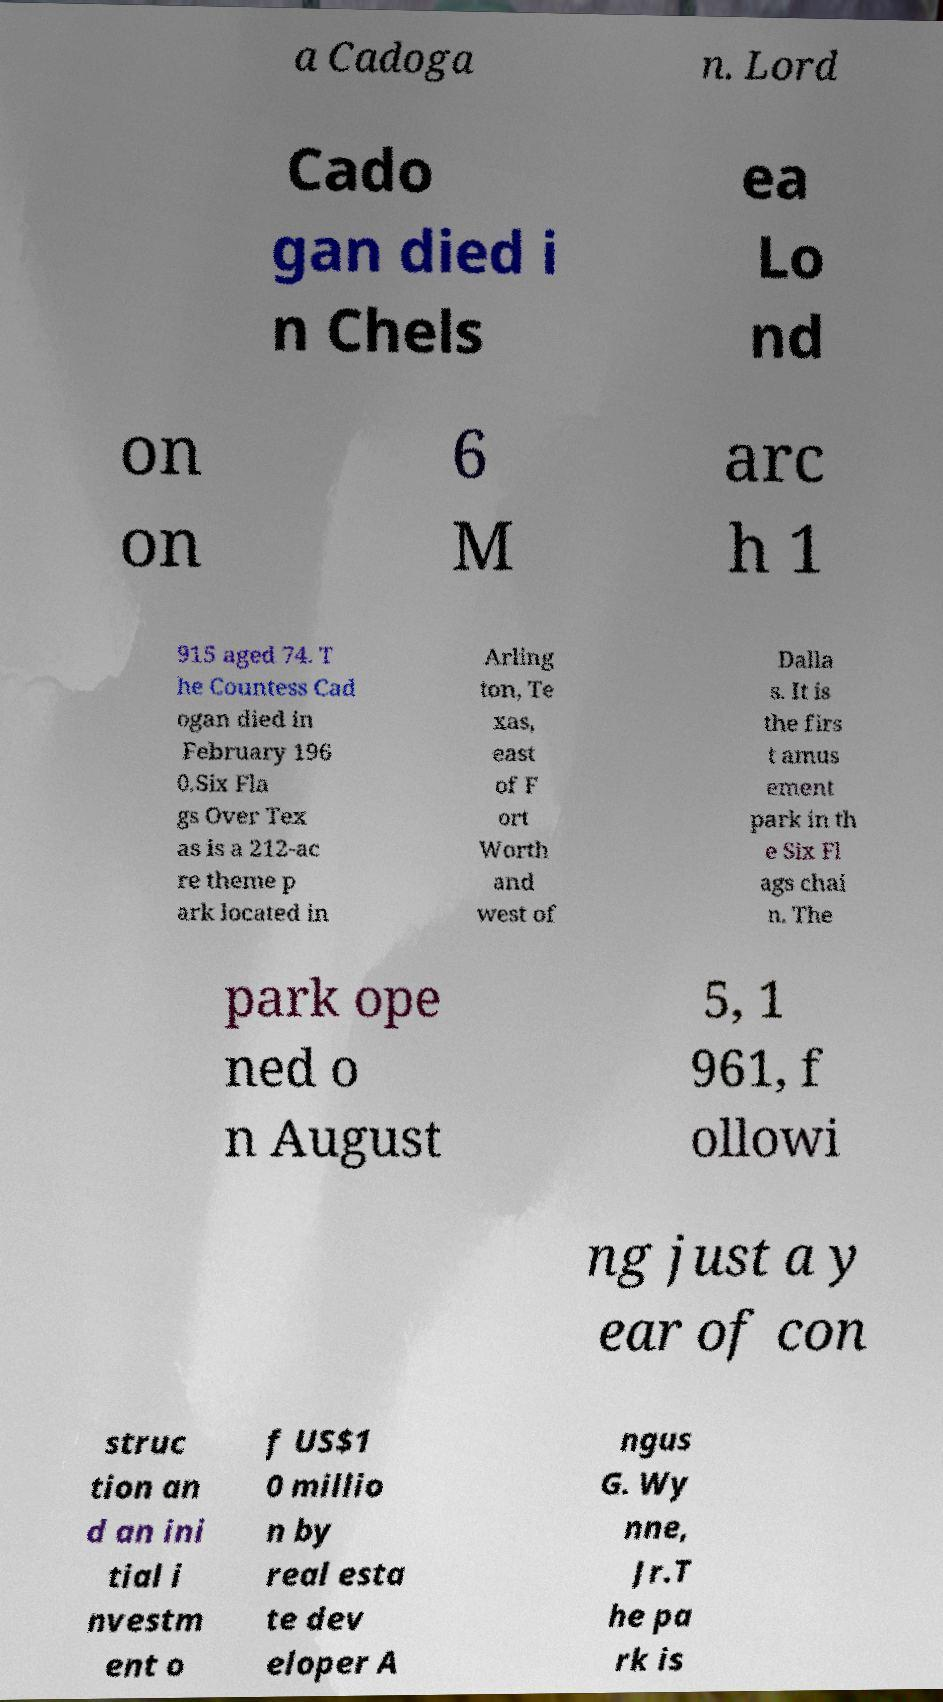I need the written content from this picture converted into text. Can you do that? a Cadoga n. Lord Cado gan died i n Chels ea Lo nd on on 6 M arc h 1 915 aged 74. T he Countess Cad ogan died in February 196 0.Six Fla gs Over Tex as is a 212-ac re theme p ark located in Arling ton, Te xas, east of F ort Worth and west of Dalla s. It is the firs t amus ement park in th e Six Fl ags chai n. The park ope ned o n August 5, 1 961, f ollowi ng just a y ear of con struc tion an d an ini tial i nvestm ent o f US$1 0 millio n by real esta te dev eloper A ngus G. Wy nne, Jr.T he pa rk is 